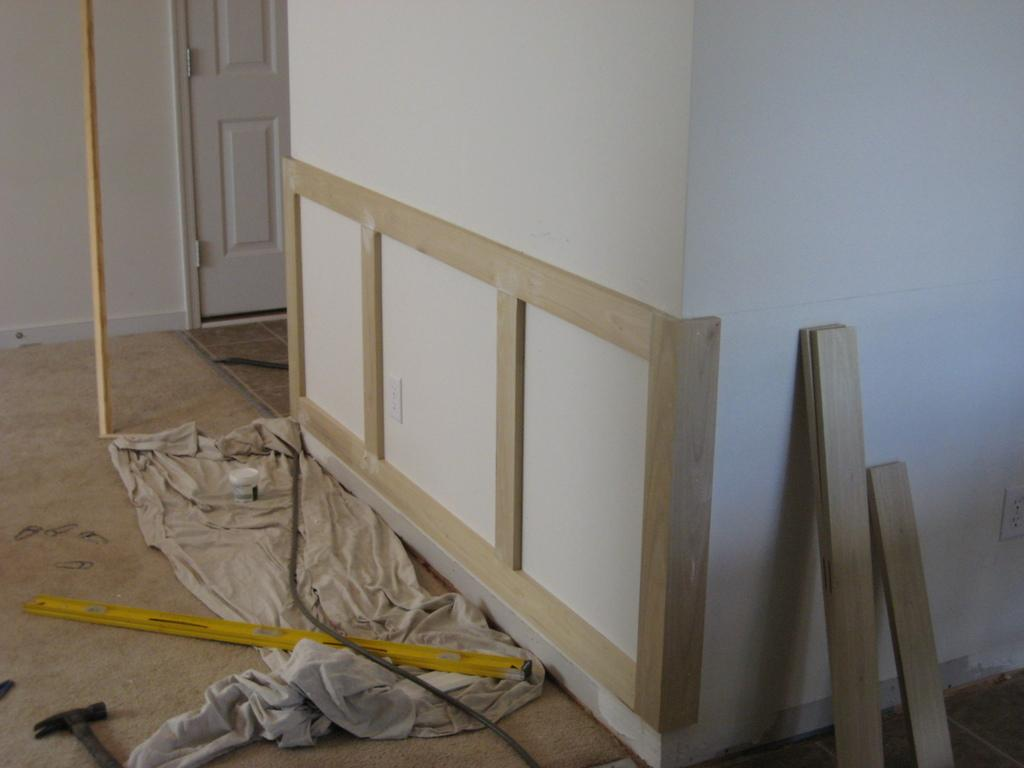What objects can be seen in the image that are used for specific tasks? There are tools in the image. What is on the floor in the image? There is cloth on the floor in the image. What type of material is present on the right side of the image? There are wooden sheets on the right side of the image. Where are the wooden sheets located in relation to the wall? The wooden sheets are in front of a wall. What is the entrance to another room in the image? There is a door to a room on the left side of the image. What phase is the moon in during the scene depicted in the image? There is no moon visible in the image, so it is not possible to determine its phase. 